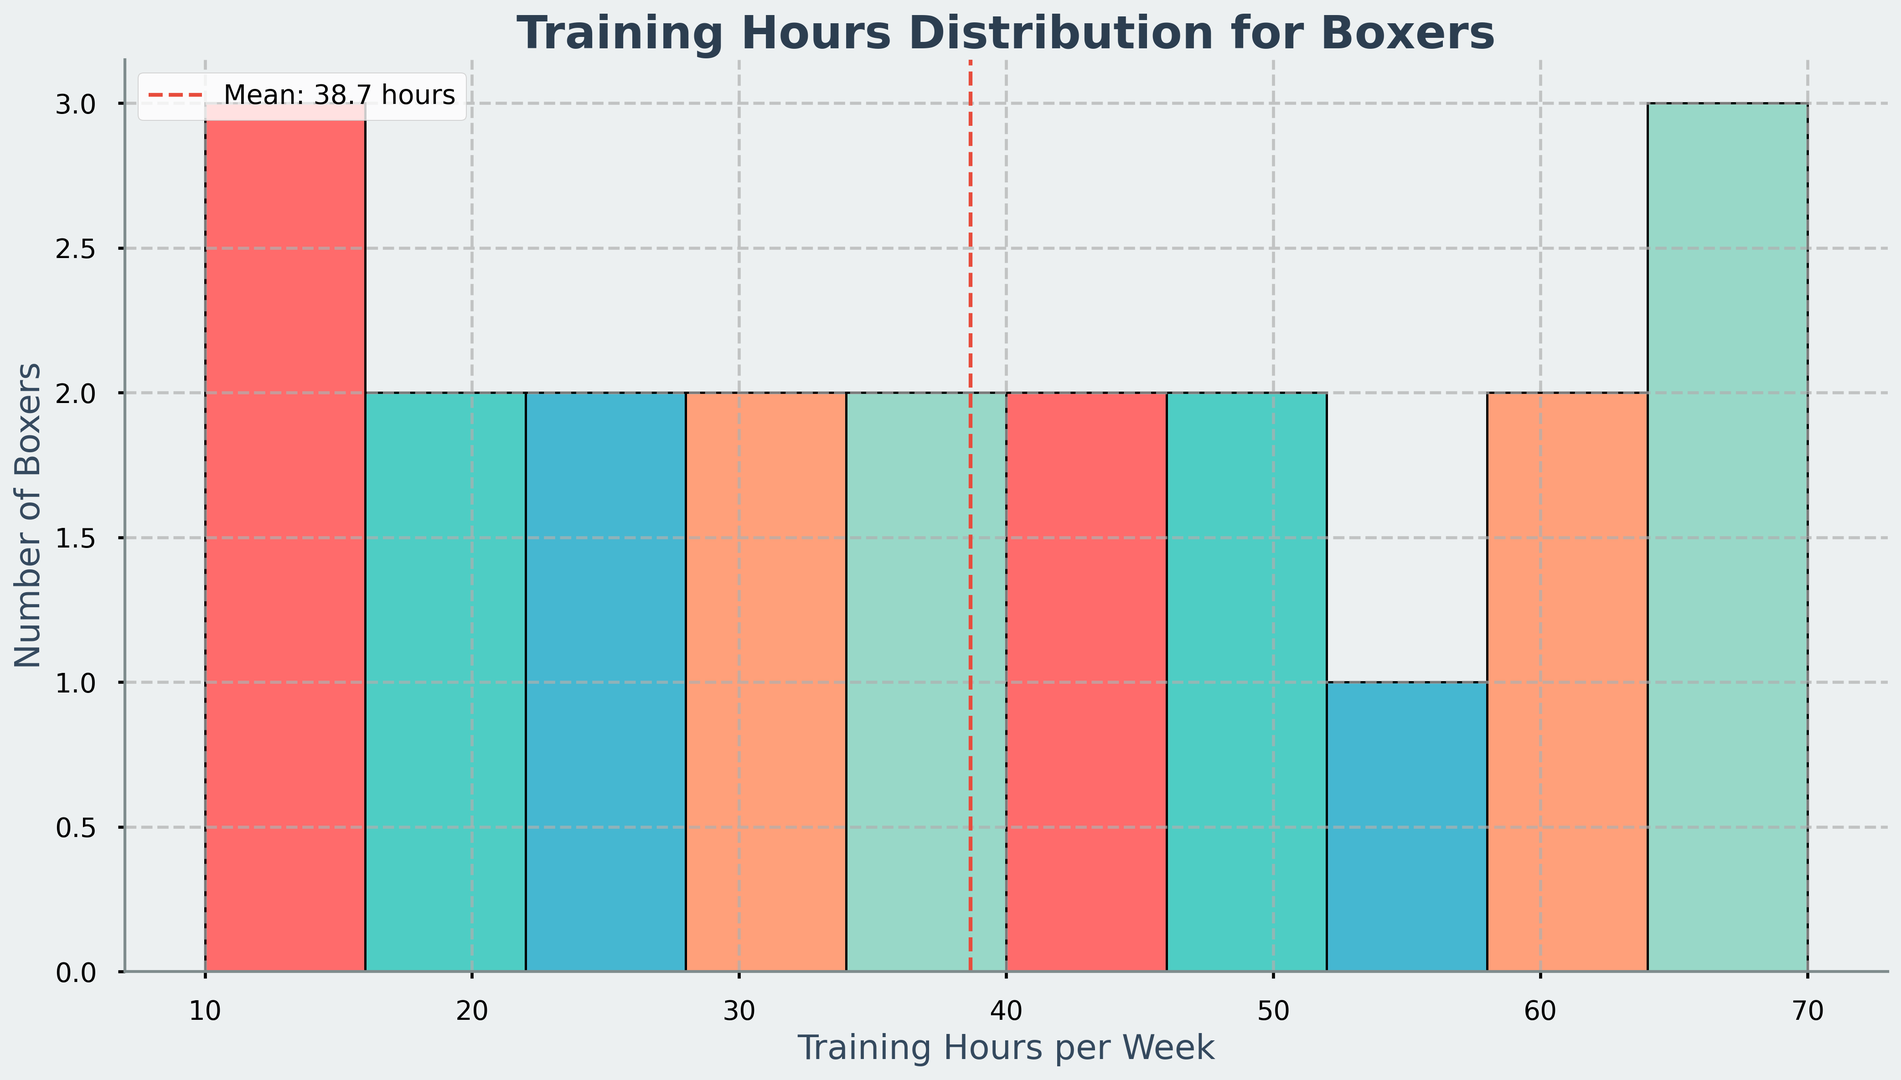What is the most common range of training hours per week? The histogram shows the frequency of different training hours ranges on the X-axis. The range with the tallest bar represents the most common range.
Answer: 18-22 hours Which career stage has the highest training hours? The highest training hours category in the histogram is represented by the tallest bar, which corresponds to the Professional Elite stage as it has the tallest collection of bars near the higher hours.
Answer: Professional Elite How many boxers train between 10 to 20 hours per week? Look at the histogram bars within the 10 to 20 hours range on the X-axis and count the frequency shown on the Y-axis.
Answer: 6 boxers What is the color of the bars that represent the 35-38 hours training range? Locate the bars corresponding to the 35-38 hours range on the X-axis and observe their color.
Answer: Green What is the average training hours per week for all career stages? The average training hours per week is represented by a vertical dashed red line in the histogram and is also labeled. It shows the mean value of training hours.
Answer: 36.5 hours How does the number of boxers training 10-20 hours compare to those training 60-70 hours per week? Observe the heights of the bars for the ranges 10-20 hours and 60-70 hours on the X-axis and compare their frequencies on the Y-axis.
Answer: Less in 10-20 hours How many training hours above the average does a "Professional Elite" boxer typically have? Find the average training hours indicated by the dashed red line, then compare it to the training hours of Professional Elite (65-70 hours). Calculate the difference.
Answer: 28.5-33.5 hours extra What is the total number of boxers represented in the lowest training hours range? The lowest training hours range is at the beginning of the X-axis, identify the bar and sum its corresponding frequencies.
Answer: 3 boxers Which range of training hours has no representation in the histogram? Identify the ranges on the X-axis where no bars are present.
Answer: 30-35 hours Which bar represents the highest number, and what career stage does it belong to? Identify the tallest bar in the histogram and observe the range it represents. Match this range with the corresponding career stage.
Answer: 65-70 hours, Professional Elite 